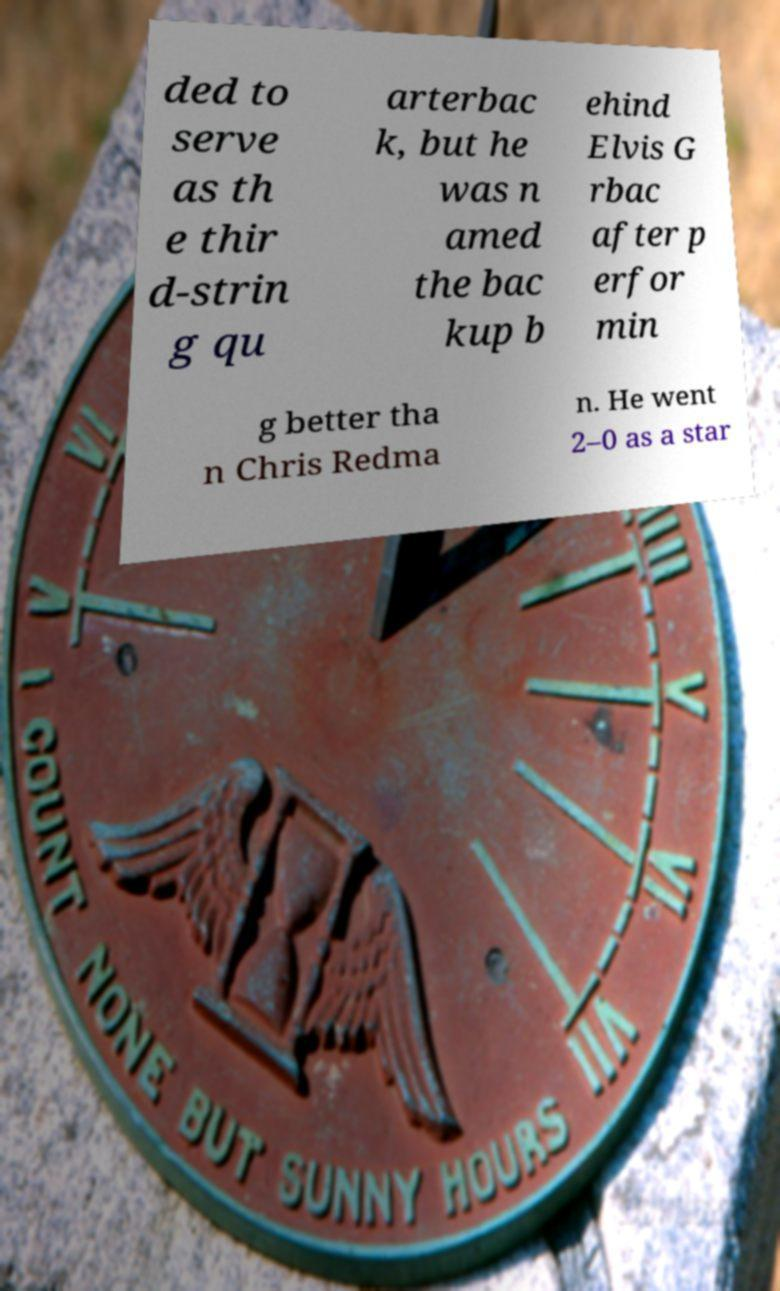I need the written content from this picture converted into text. Can you do that? ded to serve as th e thir d-strin g qu arterbac k, but he was n amed the bac kup b ehind Elvis G rbac after p erfor min g better tha n Chris Redma n. He went 2–0 as a star 